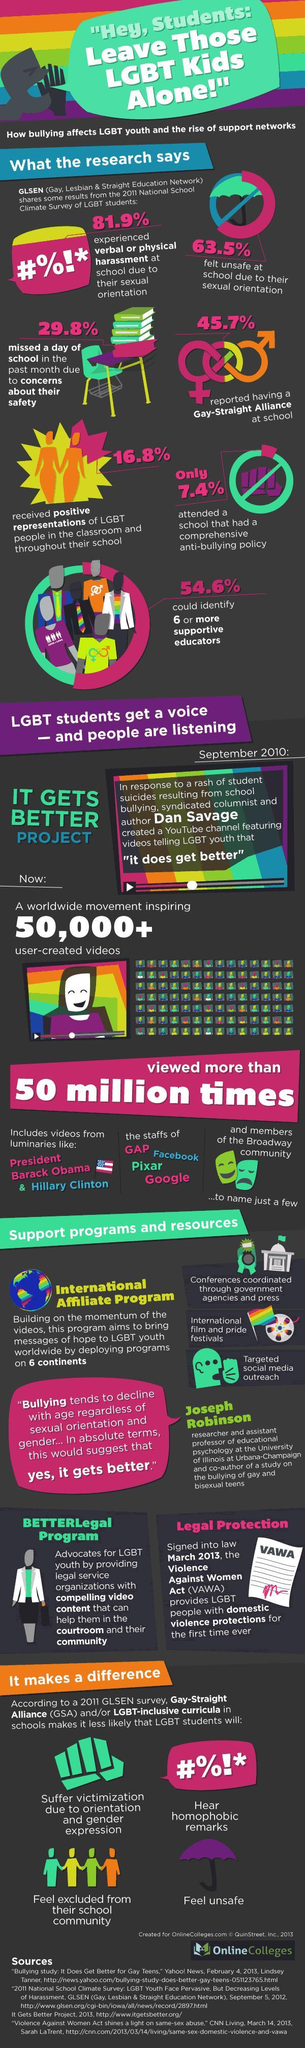What percentage of students study in a school which has best anti-bullying plans?
Answer the question with a short phrase. 7.4% What percentage of students did complain about Gay related issues? 45.7% What percentage of students have not skipped a day in school due to worrying about their safety? 70.2 